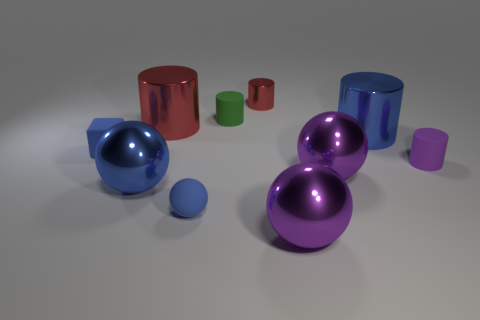Subtract all red cylinders. How many were subtracted if there are1red cylinders left? 1 Subtract all big metallic cylinders. How many cylinders are left? 3 Subtract all purple spheres. How many spheres are left? 2 Subtract all spheres. How many objects are left? 6 Subtract 1 cubes. How many cubes are left? 0 Subtract all yellow cylinders. Subtract all cyan cubes. How many cylinders are left? 5 Subtract all gray blocks. How many red cylinders are left? 2 Subtract all large purple metallic spheres. Subtract all purple cylinders. How many objects are left? 7 Add 9 blue metallic spheres. How many blue metallic spheres are left? 10 Add 7 small shiny cylinders. How many small shiny cylinders exist? 8 